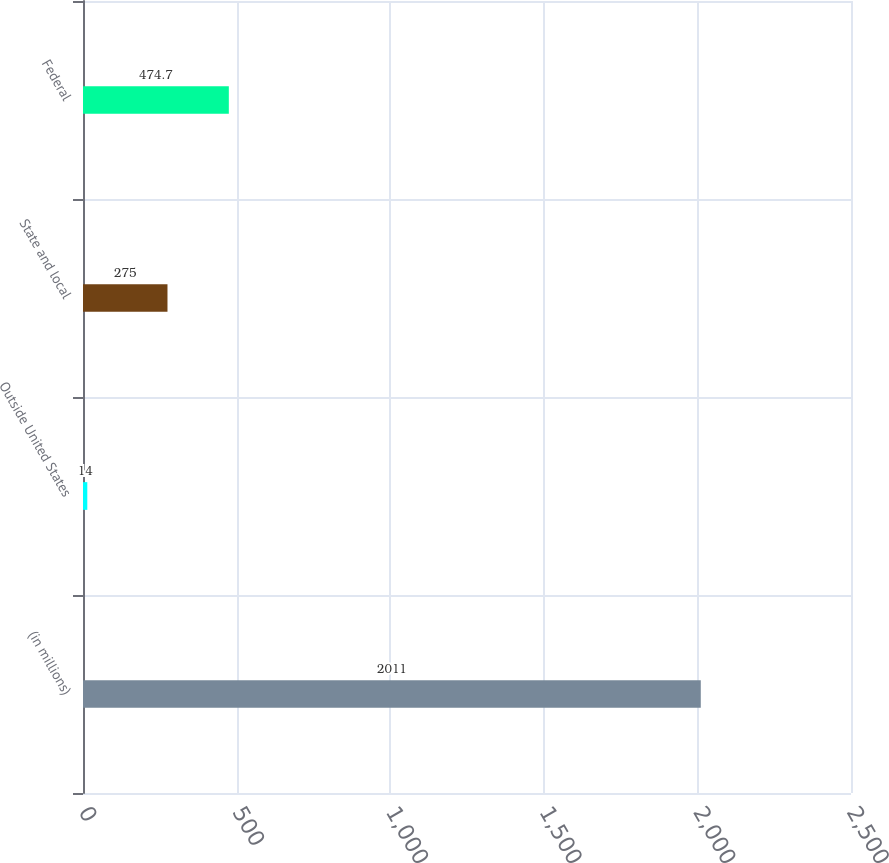<chart> <loc_0><loc_0><loc_500><loc_500><bar_chart><fcel>(in millions)<fcel>Outside United States<fcel>State and local<fcel>Federal<nl><fcel>2011<fcel>14<fcel>275<fcel>474.7<nl></chart> 